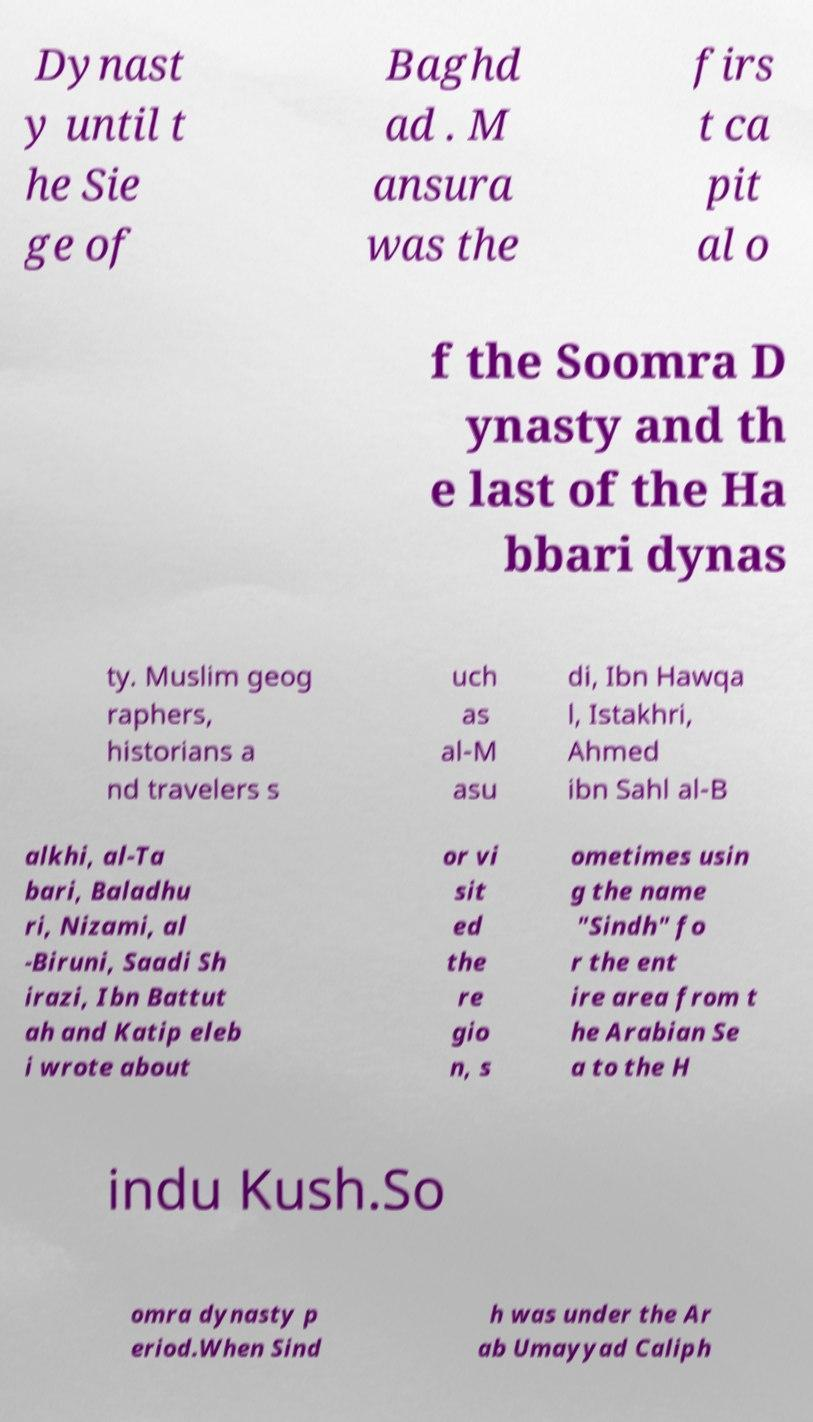For documentation purposes, I need the text within this image transcribed. Could you provide that? Dynast y until t he Sie ge of Baghd ad . M ansura was the firs t ca pit al o f the Soomra D ynasty and th e last of the Ha bbari dynas ty. Muslim geog raphers, historians a nd travelers s uch as al-M asu di, Ibn Hawqa l, Istakhri, Ahmed ibn Sahl al-B alkhi, al-Ta bari, Baladhu ri, Nizami, al -Biruni, Saadi Sh irazi, Ibn Battut ah and Katip eleb i wrote about or vi sit ed the re gio n, s ometimes usin g the name "Sindh" fo r the ent ire area from t he Arabian Se a to the H indu Kush.So omra dynasty p eriod.When Sind h was under the Ar ab Umayyad Caliph 